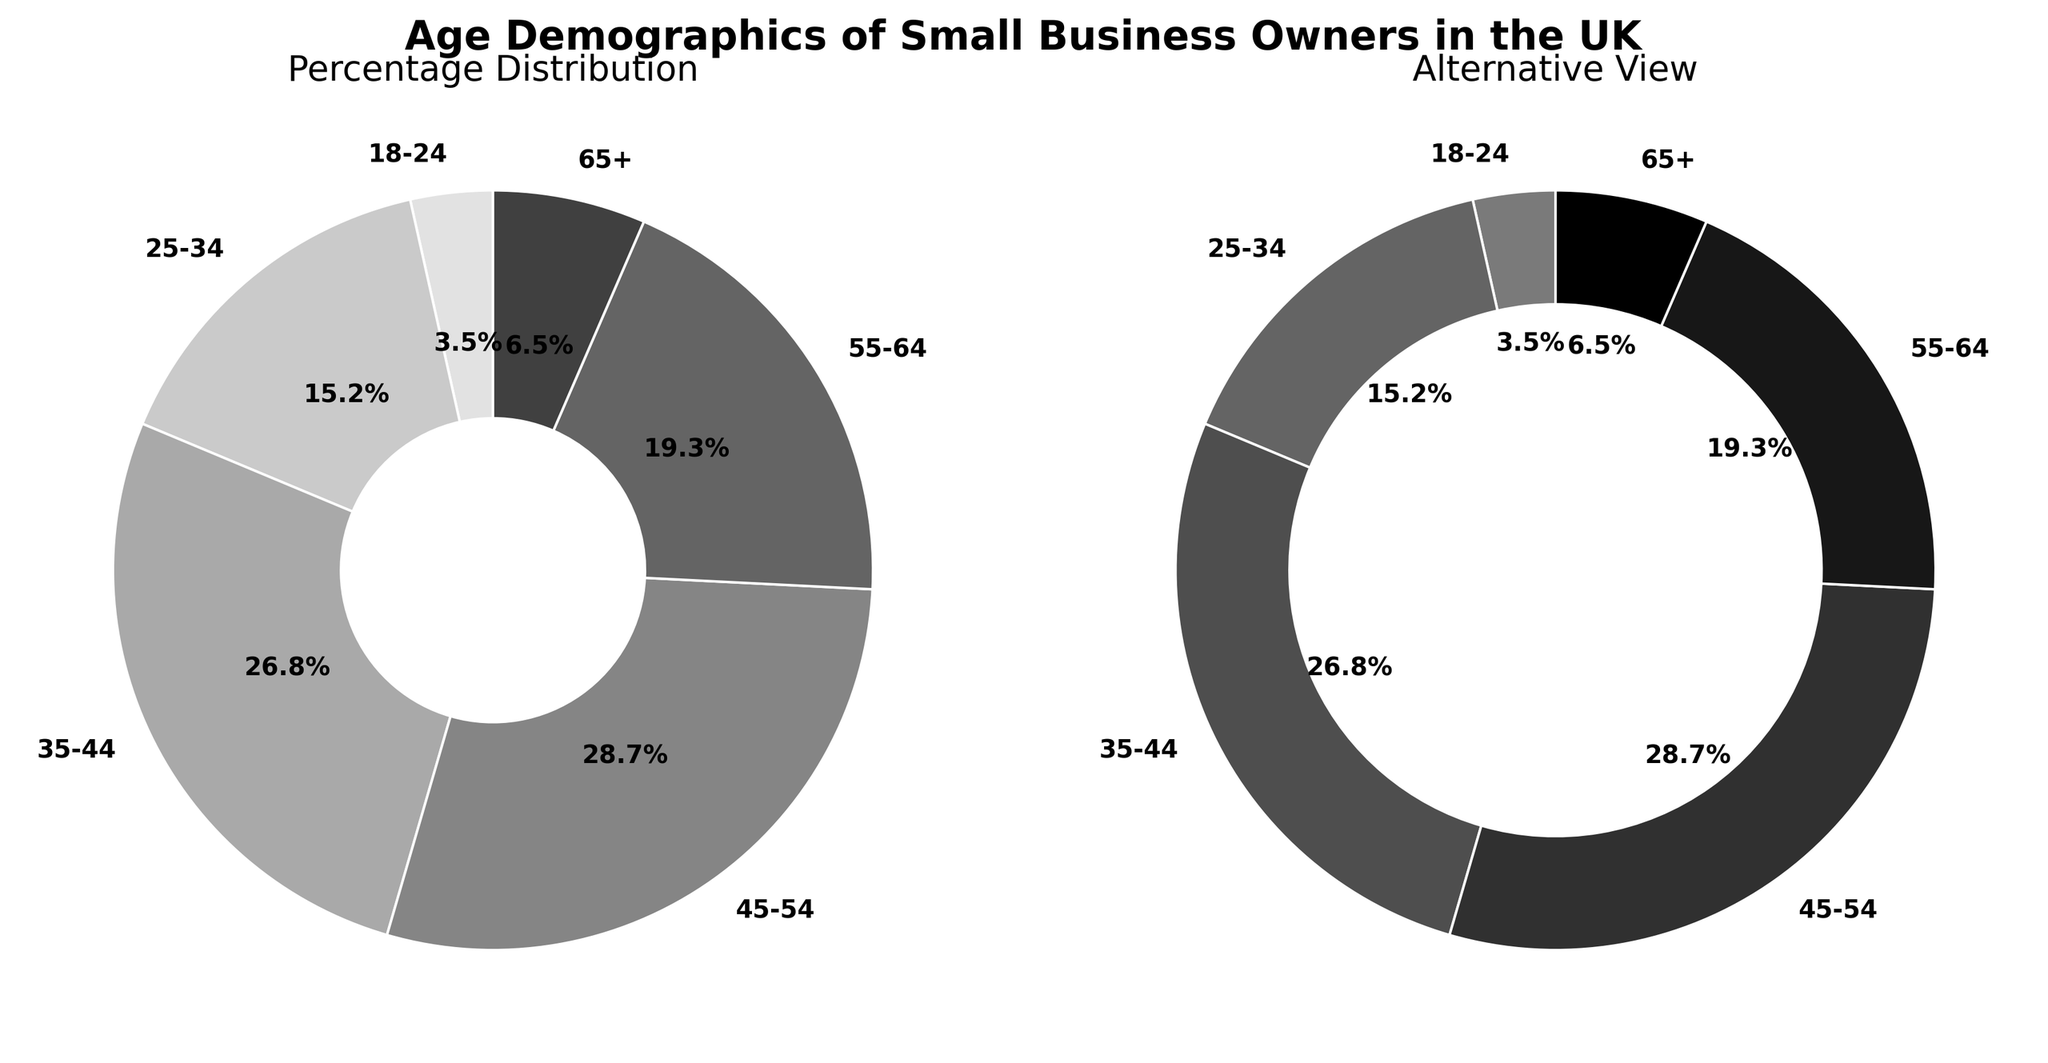What age group has the highest percentage of small business owners? The pie chart shows the percentage distribution of small business owners by age group. The largest segment is labeled 45-54 with 28.7%.
Answer: 45-54 Which age group has the lowest representation among small business owners? The pie chart indicates various age groups' percentages. The smallest segment is labeled 18-24 with 3.5%.
Answer: 18-24 What is the combined percentage of small business owners aged 35-44 and 45-54? Add the percentages for the 35-44 and 45-54 age groups. The combined total is 26.8% + 28.7% = 55.5%.
Answer: 55.5% How much more dominant are business owners aged 45-54 compared to those aged 18-24? Subtract the percentage of the 18-24 age group from the 45-54 age group. The difference is 28.7% - 3.5% = 25.2%.
Answer: 25.2% What proportion of small business owners are aged 55 or older? Add the percentages for the 55-64 and 65+ age groups. The total is 19.3% + 6.5% = 25.8%.
Answer: 25.8% Which segment of the pie chart has the lightest grey color? The pie chart segments have varying shades of grey. The segment labeled 18-24 is the lightest grey.
Answer: 18-24 How does the 25-34 age group's representation compare visually to the 35-44 age group? The pie chart segments for these age groups can be compared based on their sizes. The 35-44 segment is visually larger than the 25-34 segment, showing that the former has a higher percentage.
Answer: 35-44 is larger Estimate the average percentage of business owners for the age groups below 35 and those 35 or older. For below 35: Average of (3.5 + 15.2)/2 = 9.35%. For 35 or older: Average of (26.8 + 28.7 + 19.3 + 6.5)/4 = 20.33%.
Answer: Below 35: 9.35%, 35 or older: 20.33% What is the difference in percentage between the combined age groups of 18-24 and 25-34 compared to 55-64 alone? Sum the percentages of the 18-24 and 25-34 groups (3.5% + 15.2% = 18.7%) and subtract the percentage for 55-64 (18.7% - 19.3% = -0.6%).
Answer: -0.6% 